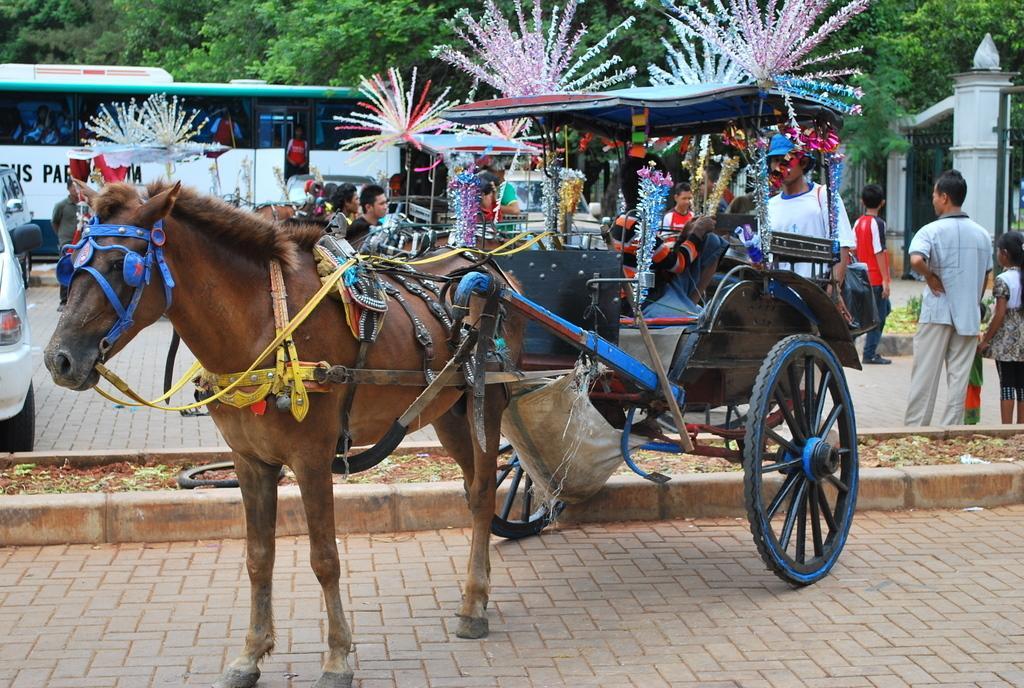Could you give a brief overview of what you see in this image? In this image we can see a horse cart on the ground which is decorated with some ribbons. On the backside we can see a tire, grass, a group of people and some vehicles on the road, a gate, pillar, a pole and a group of trees. 